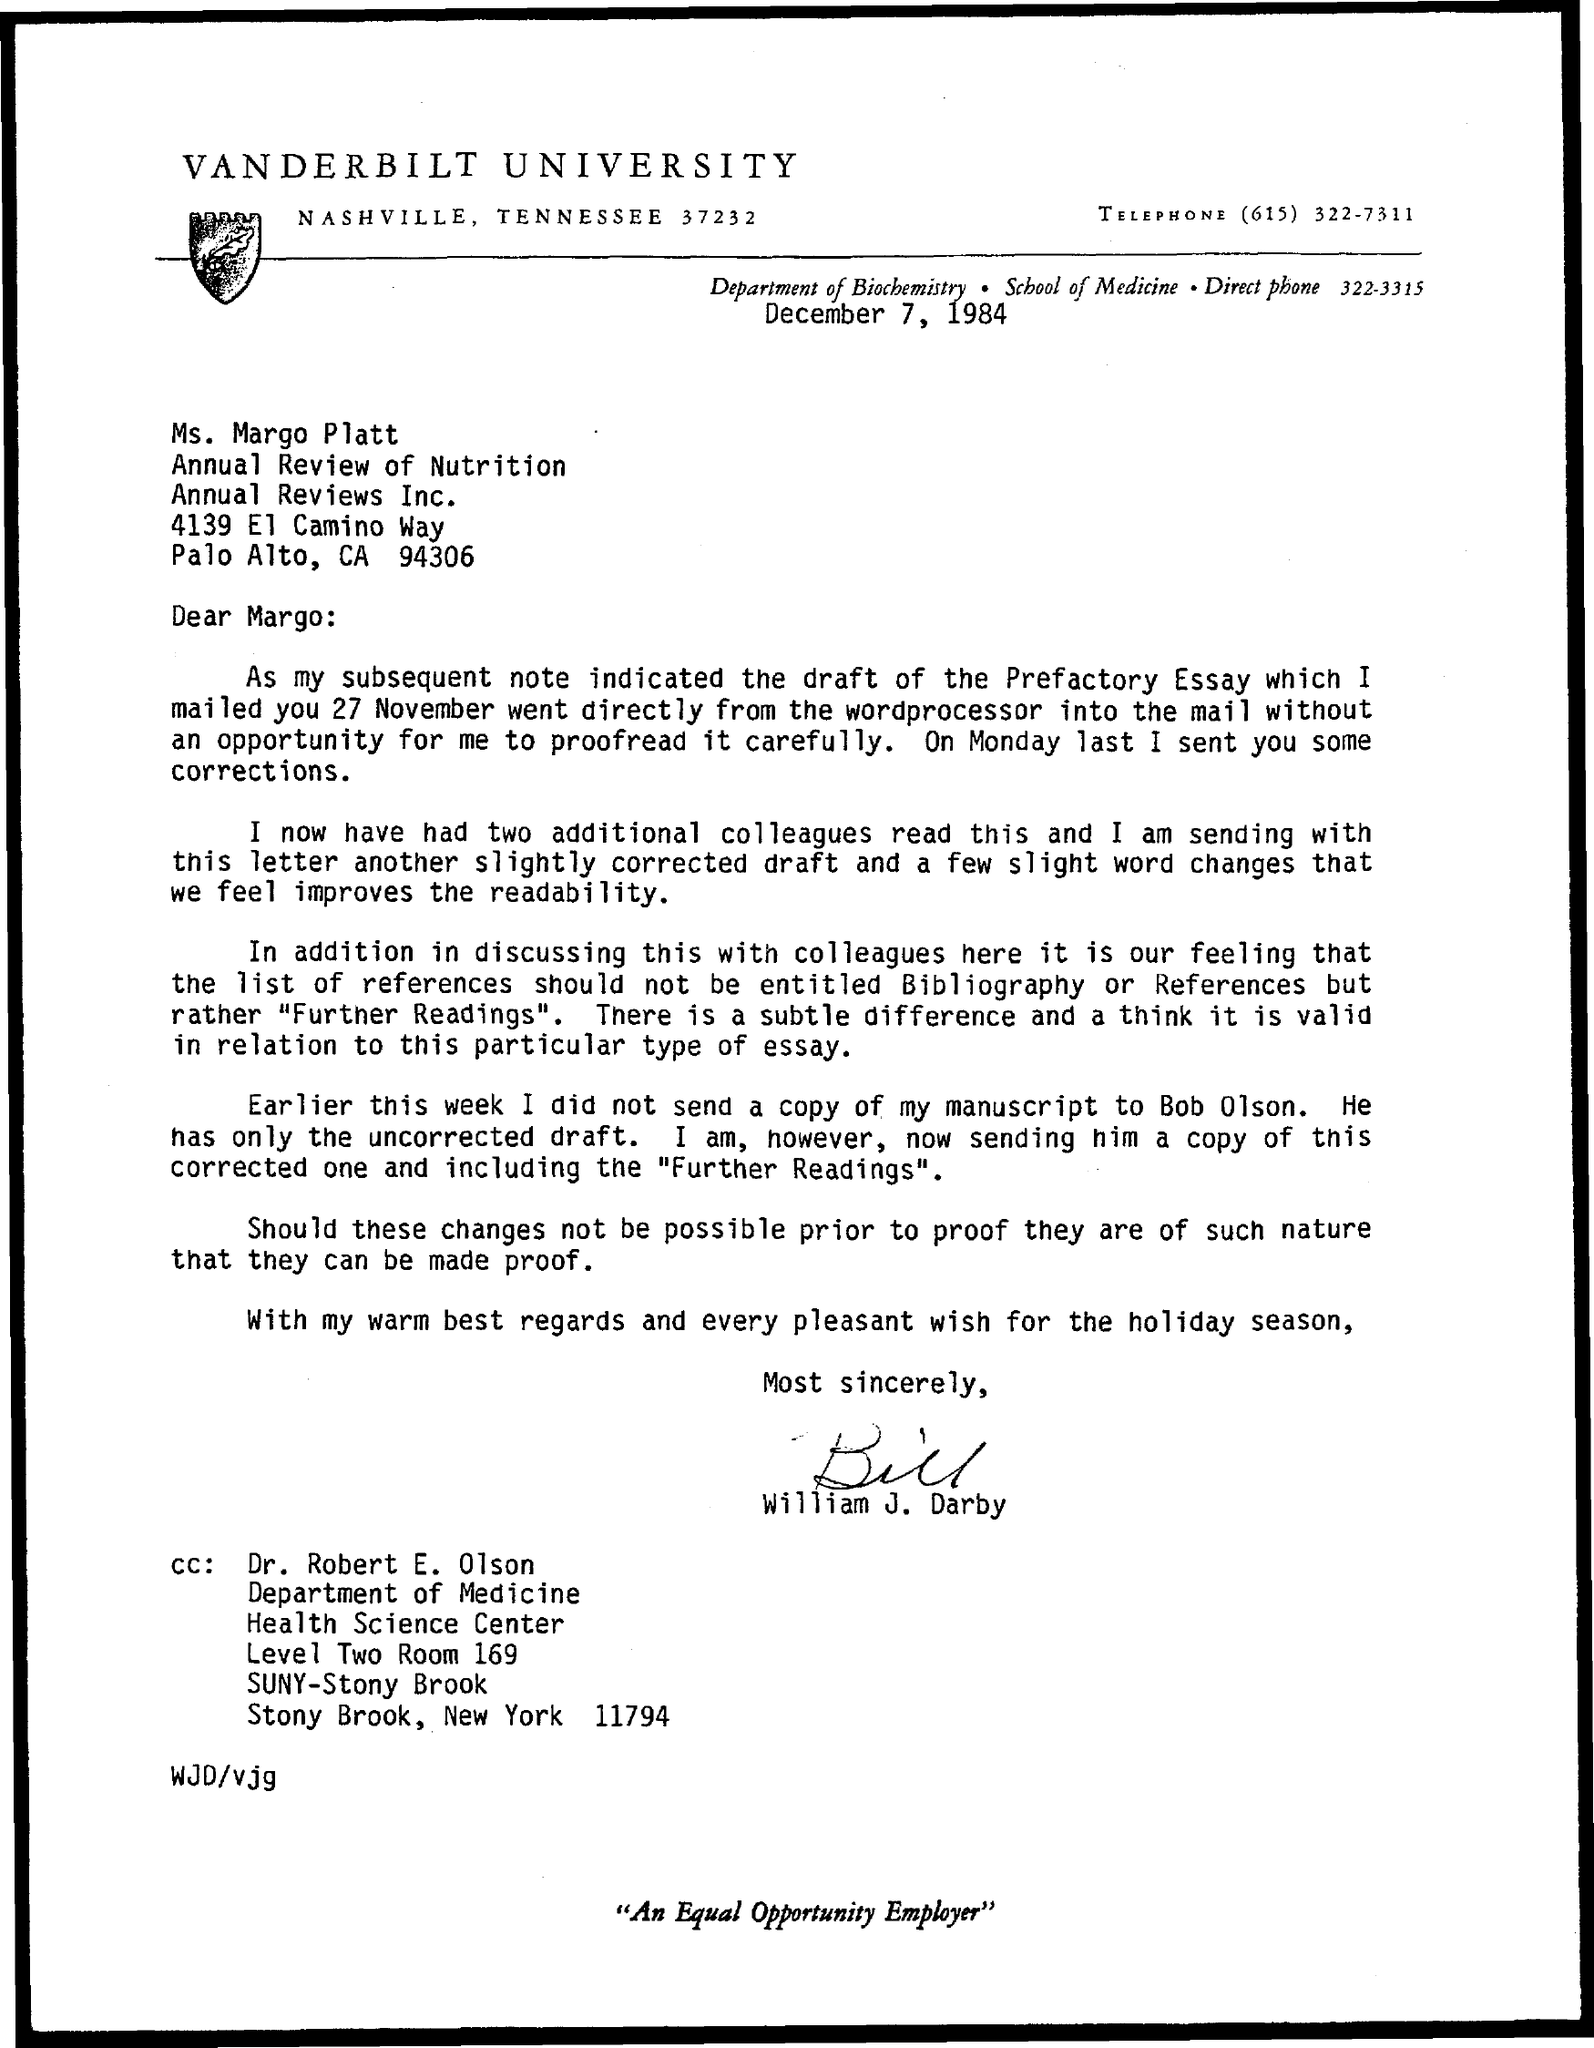Give some essential details in this illustration. December 7, 1984 is the date on which the letter was issued. The letter is addressed to Margo. 